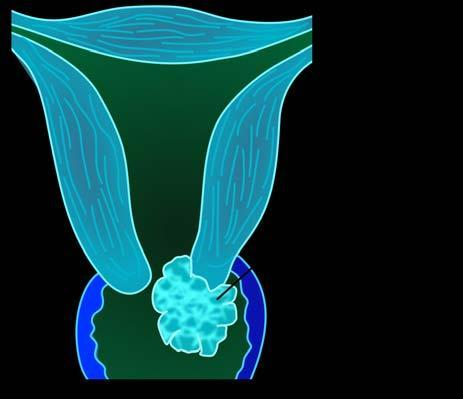s invasive carcinoma of the cervix common gross appearance of a fungating or exophytic, cauliflower-like tumour?
Answer the question using a single word or phrase. Yes 